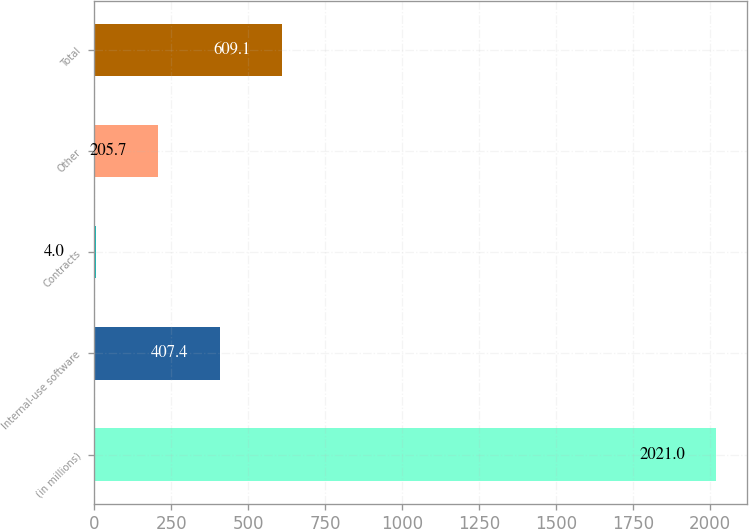<chart> <loc_0><loc_0><loc_500><loc_500><bar_chart><fcel>(in millions)<fcel>Internal-use software<fcel>Contracts<fcel>Other<fcel>Total<nl><fcel>2021<fcel>407.4<fcel>4<fcel>205.7<fcel>609.1<nl></chart> 